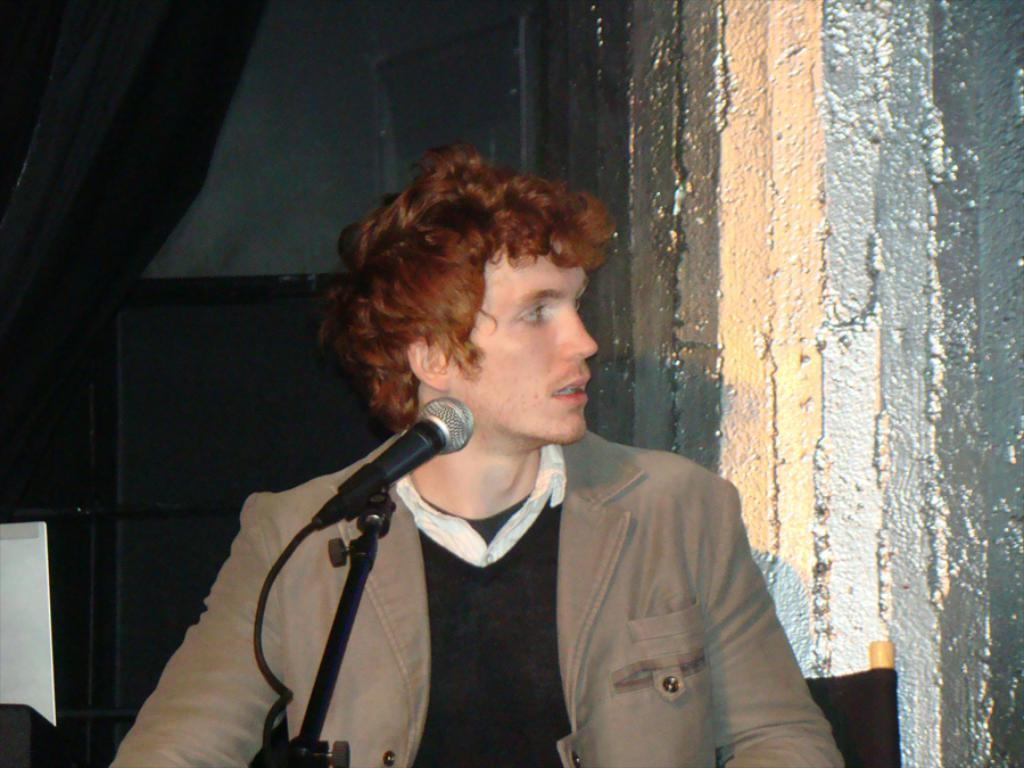Who is present in the image? There is a man in the image. What is the man doing in the image? The man is standing near a microphone. What is the man wearing in the image? The man is wearing a coat. What can be seen on the right side of the image? There is a wall on the right side of the image. What type of stove can be seen in the image? There is no stove present in the image. Is there any snow visible in the image? There is no snow visible in the image. 